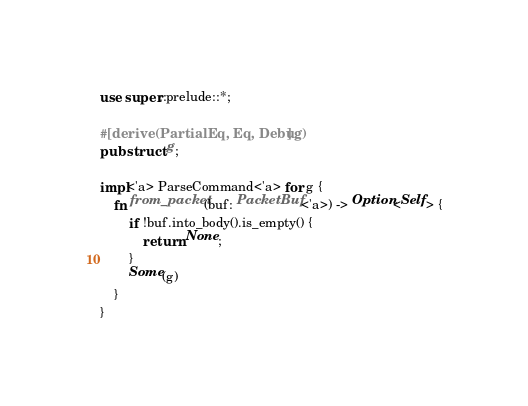<code> <loc_0><loc_0><loc_500><loc_500><_Rust_>use super::prelude::*;

#[derive(PartialEq, Eq, Debug)]
pub struct g;

impl<'a> ParseCommand<'a> for g {
    fn from_packet(buf: PacketBuf<'a>) -> Option<Self> {
        if !buf.into_body().is_empty() {
            return None;
        }
        Some(g)
    }
}
</code> 